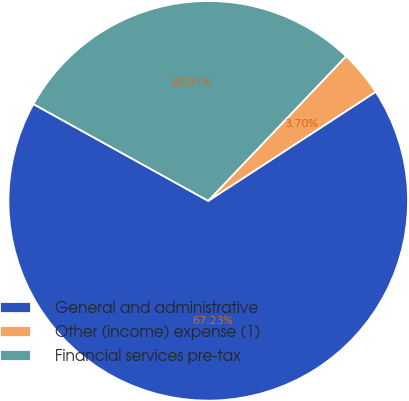<chart> <loc_0><loc_0><loc_500><loc_500><pie_chart><fcel>General and administrative<fcel>Other (income) expense (1)<fcel>Financial services pre-tax<nl><fcel>67.22%<fcel>3.7%<fcel>29.07%<nl></chart> 